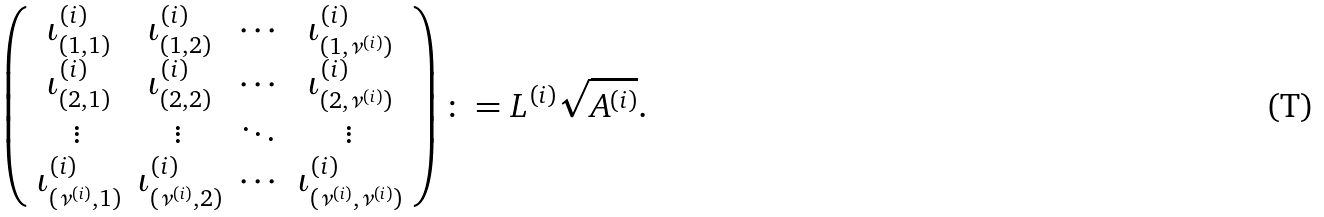Convert formula to latex. <formula><loc_0><loc_0><loc_500><loc_500>\left ( \begin{array} { c c c c } \iota _ { ( 1 , 1 ) } ^ { ( i ) } & \iota _ { ( 1 , 2 ) } ^ { ( i ) } & \cdots & \iota _ { ( 1 , \nu ^ { ( i ) } ) } ^ { ( i ) } \\ \iota _ { ( 2 , 1 ) } ^ { ( i ) } & \iota _ { ( 2 , 2 ) } ^ { ( i ) } & \cdots & \iota _ { ( 2 , \nu ^ { ( i ) } ) } ^ { ( i ) } \\ \vdots & \vdots & \ddots & \vdots \\ \iota _ { ( \nu ^ { ( i ) } , 1 ) } ^ { ( i ) } & \iota _ { ( \nu ^ { ( i ) } , 2 ) } ^ { ( i ) } & \cdots & \iota _ { ( \nu ^ { ( i ) } , \nu ^ { ( i ) } ) } ^ { ( i ) } \\ \end{array} \right ) \colon = L ^ { ( i ) } \sqrt { A ^ { ( i ) } } .</formula> 